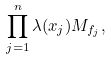Convert formula to latex. <formula><loc_0><loc_0><loc_500><loc_500>\prod _ { j = 1 } ^ { n } \lambda ( x _ { j } ) M _ { f _ { j } } ,</formula> 